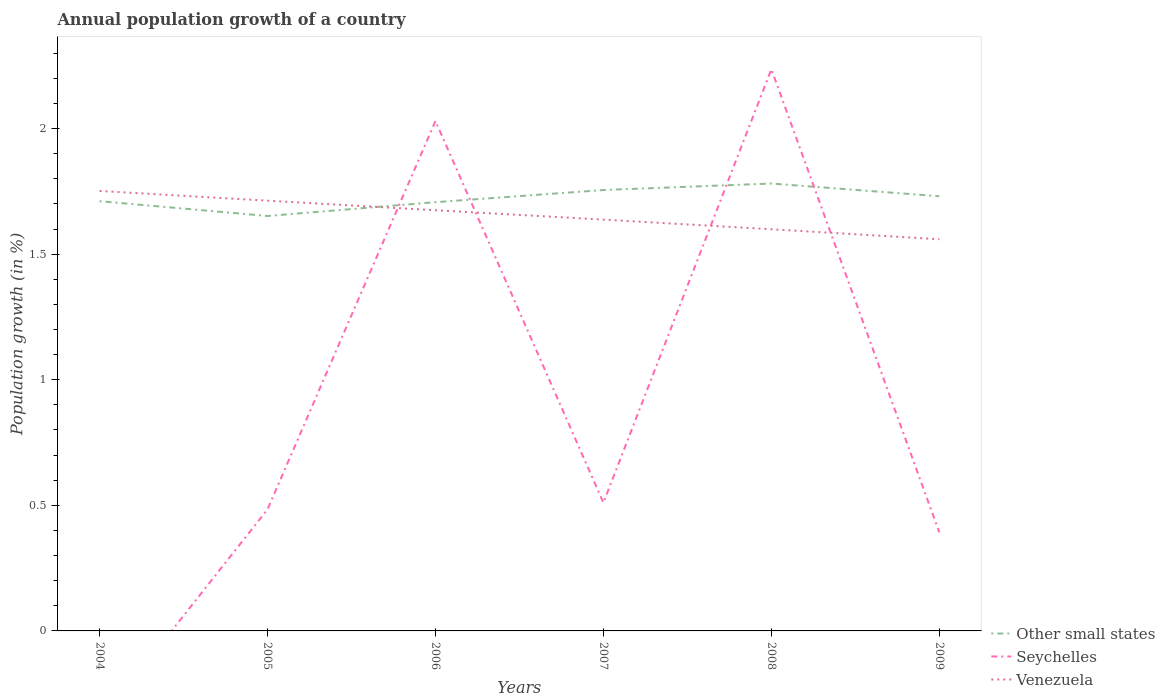How many different coloured lines are there?
Provide a short and direct response. 3. Does the line corresponding to Other small states intersect with the line corresponding to Venezuela?
Provide a short and direct response. Yes. Is the number of lines equal to the number of legend labels?
Your answer should be very brief. No. Across all years, what is the maximum annual population growth in Other small states?
Your answer should be very brief. 1.65. What is the total annual population growth in Other small states in the graph?
Offer a terse response. -0.05. What is the difference between the highest and the second highest annual population growth in Venezuela?
Provide a short and direct response. 0.19. What is the difference between the highest and the lowest annual population growth in Seychelles?
Make the answer very short. 2. Is the annual population growth in Seychelles strictly greater than the annual population growth in Other small states over the years?
Your response must be concise. No. How many lines are there?
Your answer should be very brief. 3. What is the difference between two consecutive major ticks on the Y-axis?
Ensure brevity in your answer.  0.5. Are the values on the major ticks of Y-axis written in scientific E-notation?
Provide a succinct answer. No. Does the graph contain grids?
Provide a short and direct response. No. What is the title of the graph?
Give a very brief answer. Annual population growth of a country. Does "Peru" appear as one of the legend labels in the graph?
Offer a terse response. No. What is the label or title of the X-axis?
Your answer should be compact. Years. What is the label or title of the Y-axis?
Offer a very short reply. Population growth (in %). What is the Population growth (in %) in Other small states in 2004?
Give a very brief answer. 1.71. What is the Population growth (in %) in Venezuela in 2004?
Your response must be concise. 1.75. What is the Population growth (in %) in Other small states in 2005?
Provide a succinct answer. 1.65. What is the Population growth (in %) of Seychelles in 2005?
Your response must be concise. 0.48. What is the Population growth (in %) in Venezuela in 2005?
Provide a short and direct response. 1.71. What is the Population growth (in %) in Other small states in 2006?
Your answer should be very brief. 1.71. What is the Population growth (in %) in Seychelles in 2006?
Give a very brief answer. 2.03. What is the Population growth (in %) in Venezuela in 2006?
Offer a very short reply. 1.67. What is the Population growth (in %) of Other small states in 2007?
Provide a short and direct response. 1.76. What is the Population growth (in %) of Seychelles in 2007?
Your answer should be very brief. 0.51. What is the Population growth (in %) in Venezuela in 2007?
Make the answer very short. 1.64. What is the Population growth (in %) in Other small states in 2008?
Offer a very short reply. 1.78. What is the Population growth (in %) in Seychelles in 2008?
Your answer should be very brief. 2.24. What is the Population growth (in %) of Venezuela in 2008?
Offer a very short reply. 1.6. What is the Population growth (in %) of Other small states in 2009?
Offer a very short reply. 1.73. What is the Population growth (in %) of Seychelles in 2009?
Offer a terse response. 0.39. What is the Population growth (in %) in Venezuela in 2009?
Ensure brevity in your answer.  1.56. Across all years, what is the maximum Population growth (in %) of Other small states?
Your answer should be very brief. 1.78. Across all years, what is the maximum Population growth (in %) of Seychelles?
Make the answer very short. 2.24. Across all years, what is the maximum Population growth (in %) of Venezuela?
Ensure brevity in your answer.  1.75. Across all years, what is the minimum Population growth (in %) of Other small states?
Your answer should be compact. 1.65. Across all years, what is the minimum Population growth (in %) in Venezuela?
Provide a succinct answer. 1.56. What is the total Population growth (in %) in Other small states in the graph?
Keep it short and to the point. 10.34. What is the total Population growth (in %) of Seychelles in the graph?
Ensure brevity in your answer.  5.65. What is the total Population growth (in %) of Venezuela in the graph?
Your response must be concise. 9.94. What is the difference between the Population growth (in %) in Other small states in 2004 and that in 2005?
Your response must be concise. 0.06. What is the difference between the Population growth (in %) in Venezuela in 2004 and that in 2005?
Give a very brief answer. 0.04. What is the difference between the Population growth (in %) of Other small states in 2004 and that in 2006?
Your response must be concise. 0. What is the difference between the Population growth (in %) in Venezuela in 2004 and that in 2006?
Your answer should be compact. 0.08. What is the difference between the Population growth (in %) in Other small states in 2004 and that in 2007?
Offer a terse response. -0.04. What is the difference between the Population growth (in %) of Venezuela in 2004 and that in 2007?
Your answer should be very brief. 0.11. What is the difference between the Population growth (in %) of Other small states in 2004 and that in 2008?
Offer a very short reply. -0.07. What is the difference between the Population growth (in %) in Venezuela in 2004 and that in 2008?
Offer a very short reply. 0.15. What is the difference between the Population growth (in %) in Other small states in 2004 and that in 2009?
Your answer should be compact. -0.02. What is the difference between the Population growth (in %) of Venezuela in 2004 and that in 2009?
Your answer should be very brief. 0.19. What is the difference between the Population growth (in %) of Other small states in 2005 and that in 2006?
Offer a very short reply. -0.05. What is the difference between the Population growth (in %) in Seychelles in 2005 and that in 2006?
Your answer should be compact. -1.55. What is the difference between the Population growth (in %) in Venezuela in 2005 and that in 2006?
Offer a terse response. 0.04. What is the difference between the Population growth (in %) in Other small states in 2005 and that in 2007?
Give a very brief answer. -0.1. What is the difference between the Population growth (in %) of Seychelles in 2005 and that in 2007?
Ensure brevity in your answer.  -0.03. What is the difference between the Population growth (in %) in Venezuela in 2005 and that in 2007?
Ensure brevity in your answer.  0.08. What is the difference between the Population growth (in %) of Other small states in 2005 and that in 2008?
Offer a terse response. -0.13. What is the difference between the Population growth (in %) in Seychelles in 2005 and that in 2008?
Make the answer very short. -1.75. What is the difference between the Population growth (in %) of Venezuela in 2005 and that in 2008?
Offer a terse response. 0.11. What is the difference between the Population growth (in %) in Other small states in 2005 and that in 2009?
Your response must be concise. -0.08. What is the difference between the Population growth (in %) of Seychelles in 2005 and that in 2009?
Make the answer very short. 0.09. What is the difference between the Population growth (in %) in Venezuela in 2005 and that in 2009?
Your answer should be compact. 0.15. What is the difference between the Population growth (in %) of Other small states in 2006 and that in 2007?
Your response must be concise. -0.05. What is the difference between the Population growth (in %) of Seychelles in 2006 and that in 2007?
Make the answer very short. 1.52. What is the difference between the Population growth (in %) in Venezuela in 2006 and that in 2007?
Make the answer very short. 0.04. What is the difference between the Population growth (in %) in Other small states in 2006 and that in 2008?
Provide a succinct answer. -0.07. What is the difference between the Population growth (in %) of Seychelles in 2006 and that in 2008?
Offer a terse response. -0.21. What is the difference between the Population growth (in %) in Venezuela in 2006 and that in 2008?
Give a very brief answer. 0.08. What is the difference between the Population growth (in %) in Other small states in 2006 and that in 2009?
Ensure brevity in your answer.  -0.02. What is the difference between the Population growth (in %) in Seychelles in 2006 and that in 2009?
Provide a short and direct response. 1.64. What is the difference between the Population growth (in %) of Venezuela in 2006 and that in 2009?
Keep it short and to the point. 0.12. What is the difference between the Population growth (in %) of Other small states in 2007 and that in 2008?
Offer a terse response. -0.03. What is the difference between the Population growth (in %) in Seychelles in 2007 and that in 2008?
Provide a succinct answer. -1.73. What is the difference between the Population growth (in %) of Venezuela in 2007 and that in 2008?
Ensure brevity in your answer.  0.04. What is the difference between the Population growth (in %) of Other small states in 2007 and that in 2009?
Offer a terse response. 0.02. What is the difference between the Population growth (in %) of Seychelles in 2007 and that in 2009?
Offer a very short reply. 0.12. What is the difference between the Population growth (in %) in Venezuela in 2007 and that in 2009?
Your answer should be very brief. 0.08. What is the difference between the Population growth (in %) of Other small states in 2008 and that in 2009?
Make the answer very short. 0.05. What is the difference between the Population growth (in %) of Seychelles in 2008 and that in 2009?
Your answer should be very brief. 1.84. What is the difference between the Population growth (in %) in Venezuela in 2008 and that in 2009?
Give a very brief answer. 0.04. What is the difference between the Population growth (in %) in Other small states in 2004 and the Population growth (in %) in Seychelles in 2005?
Your answer should be very brief. 1.23. What is the difference between the Population growth (in %) of Other small states in 2004 and the Population growth (in %) of Venezuela in 2005?
Give a very brief answer. -0. What is the difference between the Population growth (in %) of Other small states in 2004 and the Population growth (in %) of Seychelles in 2006?
Keep it short and to the point. -0.32. What is the difference between the Population growth (in %) in Other small states in 2004 and the Population growth (in %) in Venezuela in 2006?
Ensure brevity in your answer.  0.04. What is the difference between the Population growth (in %) of Other small states in 2004 and the Population growth (in %) of Seychelles in 2007?
Your answer should be compact. 1.2. What is the difference between the Population growth (in %) of Other small states in 2004 and the Population growth (in %) of Venezuela in 2007?
Provide a short and direct response. 0.07. What is the difference between the Population growth (in %) of Other small states in 2004 and the Population growth (in %) of Seychelles in 2008?
Provide a short and direct response. -0.53. What is the difference between the Population growth (in %) in Other small states in 2004 and the Population growth (in %) in Venezuela in 2008?
Provide a succinct answer. 0.11. What is the difference between the Population growth (in %) of Other small states in 2004 and the Population growth (in %) of Seychelles in 2009?
Make the answer very short. 1.32. What is the difference between the Population growth (in %) of Other small states in 2004 and the Population growth (in %) of Venezuela in 2009?
Offer a terse response. 0.15. What is the difference between the Population growth (in %) in Other small states in 2005 and the Population growth (in %) in Seychelles in 2006?
Offer a very short reply. -0.38. What is the difference between the Population growth (in %) of Other small states in 2005 and the Population growth (in %) of Venezuela in 2006?
Provide a succinct answer. -0.02. What is the difference between the Population growth (in %) in Seychelles in 2005 and the Population growth (in %) in Venezuela in 2006?
Your answer should be compact. -1.19. What is the difference between the Population growth (in %) in Other small states in 2005 and the Population growth (in %) in Seychelles in 2007?
Make the answer very short. 1.14. What is the difference between the Population growth (in %) of Other small states in 2005 and the Population growth (in %) of Venezuela in 2007?
Give a very brief answer. 0.01. What is the difference between the Population growth (in %) in Seychelles in 2005 and the Population growth (in %) in Venezuela in 2007?
Keep it short and to the point. -1.15. What is the difference between the Population growth (in %) of Other small states in 2005 and the Population growth (in %) of Seychelles in 2008?
Give a very brief answer. -0.58. What is the difference between the Population growth (in %) in Other small states in 2005 and the Population growth (in %) in Venezuela in 2008?
Your answer should be very brief. 0.05. What is the difference between the Population growth (in %) of Seychelles in 2005 and the Population growth (in %) of Venezuela in 2008?
Make the answer very short. -1.12. What is the difference between the Population growth (in %) of Other small states in 2005 and the Population growth (in %) of Seychelles in 2009?
Make the answer very short. 1.26. What is the difference between the Population growth (in %) in Other small states in 2005 and the Population growth (in %) in Venezuela in 2009?
Provide a succinct answer. 0.09. What is the difference between the Population growth (in %) of Seychelles in 2005 and the Population growth (in %) of Venezuela in 2009?
Provide a short and direct response. -1.08. What is the difference between the Population growth (in %) in Other small states in 2006 and the Population growth (in %) in Seychelles in 2007?
Your answer should be compact. 1.2. What is the difference between the Population growth (in %) in Other small states in 2006 and the Population growth (in %) in Venezuela in 2007?
Ensure brevity in your answer.  0.07. What is the difference between the Population growth (in %) in Seychelles in 2006 and the Population growth (in %) in Venezuela in 2007?
Give a very brief answer. 0.39. What is the difference between the Population growth (in %) of Other small states in 2006 and the Population growth (in %) of Seychelles in 2008?
Keep it short and to the point. -0.53. What is the difference between the Population growth (in %) of Other small states in 2006 and the Population growth (in %) of Venezuela in 2008?
Offer a terse response. 0.11. What is the difference between the Population growth (in %) of Seychelles in 2006 and the Population growth (in %) of Venezuela in 2008?
Keep it short and to the point. 0.43. What is the difference between the Population growth (in %) of Other small states in 2006 and the Population growth (in %) of Seychelles in 2009?
Your response must be concise. 1.31. What is the difference between the Population growth (in %) in Other small states in 2006 and the Population growth (in %) in Venezuela in 2009?
Provide a short and direct response. 0.15. What is the difference between the Population growth (in %) of Seychelles in 2006 and the Population growth (in %) of Venezuela in 2009?
Offer a terse response. 0.47. What is the difference between the Population growth (in %) in Other small states in 2007 and the Population growth (in %) in Seychelles in 2008?
Ensure brevity in your answer.  -0.48. What is the difference between the Population growth (in %) in Other small states in 2007 and the Population growth (in %) in Venezuela in 2008?
Your answer should be very brief. 0.16. What is the difference between the Population growth (in %) of Seychelles in 2007 and the Population growth (in %) of Venezuela in 2008?
Provide a short and direct response. -1.09. What is the difference between the Population growth (in %) of Other small states in 2007 and the Population growth (in %) of Seychelles in 2009?
Give a very brief answer. 1.36. What is the difference between the Population growth (in %) in Other small states in 2007 and the Population growth (in %) in Venezuela in 2009?
Ensure brevity in your answer.  0.2. What is the difference between the Population growth (in %) of Seychelles in 2007 and the Population growth (in %) of Venezuela in 2009?
Provide a short and direct response. -1.05. What is the difference between the Population growth (in %) in Other small states in 2008 and the Population growth (in %) in Seychelles in 2009?
Keep it short and to the point. 1.39. What is the difference between the Population growth (in %) in Other small states in 2008 and the Population growth (in %) in Venezuela in 2009?
Your answer should be very brief. 0.22. What is the difference between the Population growth (in %) of Seychelles in 2008 and the Population growth (in %) of Venezuela in 2009?
Provide a short and direct response. 0.68. What is the average Population growth (in %) in Other small states per year?
Keep it short and to the point. 1.72. What is the average Population growth (in %) of Seychelles per year?
Ensure brevity in your answer.  0.94. What is the average Population growth (in %) of Venezuela per year?
Offer a very short reply. 1.66. In the year 2004, what is the difference between the Population growth (in %) in Other small states and Population growth (in %) in Venezuela?
Offer a very short reply. -0.04. In the year 2005, what is the difference between the Population growth (in %) in Other small states and Population growth (in %) in Seychelles?
Keep it short and to the point. 1.17. In the year 2005, what is the difference between the Population growth (in %) in Other small states and Population growth (in %) in Venezuela?
Ensure brevity in your answer.  -0.06. In the year 2005, what is the difference between the Population growth (in %) of Seychelles and Population growth (in %) of Venezuela?
Your answer should be very brief. -1.23. In the year 2006, what is the difference between the Population growth (in %) of Other small states and Population growth (in %) of Seychelles?
Give a very brief answer. -0.32. In the year 2006, what is the difference between the Population growth (in %) in Other small states and Population growth (in %) in Venezuela?
Keep it short and to the point. 0.03. In the year 2006, what is the difference between the Population growth (in %) of Seychelles and Population growth (in %) of Venezuela?
Offer a terse response. 0.36. In the year 2007, what is the difference between the Population growth (in %) of Other small states and Population growth (in %) of Seychelles?
Keep it short and to the point. 1.24. In the year 2007, what is the difference between the Population growth (in %) of Other small states and Population growth (in %) of Venezuela?
Provide a succinct answer. 0.12. In the year 2007, what is the difference between the Population growth (in %) in Seychelles and Population growth (in %) in Venezuela?
Offer a very short reply. -1.13. In the year 2008, what is the difference between the Population growth (in %) in Other small states and Population growth (in %) in Seychelles?
Offer a very short reply. -0.46. In the year 2008, what is the difference between the Population growth (in %) of Other small states and Population growth (in %) of Venezuela?
Your answer should be compact. 0.18. In the year 2008, what is the difference between the Population growth (in %) in Seychelles and Population growth (in %) in Venezuela?
Ensure brevity in your answer.  0.64. In the year 2009, what is the difference between the Population growth (in %) of Other small states and Population growth (in %) of Seychelles?
Provide a succinct answer. 1.34. In the year 2009, what is the difference between the Population growth (in %) in Other small states and Population growth (in %) in Venezuela?
Give a very brief answer. 0.17. In the year 2009, what is the difference between the Population growth (in %) of Seychelles and Population growth (in %) of Venezuela?
Your answer should be compact. -1.17. What is the ratio of the Population growth (in %) in Other small states in 2004 to that in 2005?
Give a very brief answer. 1.04. What is the ratio of the Population growth (in %) in Venezuela in 2004 to that in 2005?
Ensure brevity in your answer.  1.02. What is the ratio of the Population growth (in %) of Venezuela in 2004 to that in 2006?
Ensure brevity in your answer.  1.05. What is the ratio of the Population growth (in %) in Other small states in 2004 to that in 2007?
Your response must be concise. 0.97. What is the ratio of the Population growth (in %) in Venezuela in 2004 to that in 2007?
Ensure brevity in your answer.  1.07. What is the ratio of the Population growth (in %) of Other small states in 2004 to that in 2008?
Provide a succinct answer. 0.96. What is the ratio of the Population growth (in %) of Venezuela in 2004 to that in 2008?
Make the answer very short. 1.1. What is the ratio of the Population growth (in %) of Venezuela in 2004 to that in 2009?
Provide a succinct answer. 1.12. What is the ratio of the Population growth (in %) of Other small states in 2005 to that in 2006?
Provide a succinct answer. 0.97. What is the ratio of the Population growth (in %) in Seychelles in 2005 to that in 2006?
Give a very brief answer. 0.24. What is the ratio of the Population growth (in %) of Venezuela in 2005 to that in 2006?
Keep it short and to the point. 1.02. What is the ratio of the Population growth (in %) of Other small states in 2005 to that in 2007?
Offer a very short reply. 0.94. What is the ratio of the Population growth (in %) in Seychelles in 2005 to that in 2007?
Provide a short and direct response. 0.95. What is the ratio of the Population growth (in %) of Venezuela in 2005 to that in 2007?
Provide a succinct answer. 1.05. What is the ratio of the Population growth (in %) in Other small states in 2005 to that in 2008?
Give a very brief answer. 0.93. What is the ratio of the Population growth (in %) of Seychelles in 2005 to that in 2008?
Provide a succinct answer. 0.22. What is the ratio of the Population growth (in %) of Venezuela in 2005 to that in 2008?
Keep it short and to the point. 1.07. What is the ratio of the Population growth (in %) in Other small states in 2005 to that in 2009?
Ensure brevity in your answer.  0.95. What is the ratio of the Population growth (in %) of Seychelles in 2005 to that in 2009?
Make the answer very short. 1.23. What is the ratio of the Population growth (in %) in Venezuela in 2005 to that in 2009?
Provide a succinct answer. 1.1. What is the ratio of the Population growth (in %) of Other small states in 2006 to that in 2007?
Provide a short and direct response. 0.97. What is the ratio of the Population growth (in %) of Seychelles in 2006 to that in 2007?
Offer a very short reply. 3.98. What is the ratio of the Population growth (in %) in Venezuela in 2006 to that in 2007?
Your response must be concise. 1.02. What is the ratio of the Population growth (in %) in Seychelles in 2006 to that in 2008?
Give a very brief answer. 0.91. What is the ratio of the Population growth (in %) of Venezuela in 2006 to that in 2008?
Provide a succinct answer. 1.05. What is the ratio of the Population growth (in %) in Other small states in 2006 to that in 2009?
Give a very brief answer. 0.99. What is the ratio of the Population growth (in %) of Seychelles in 2006 to that in 2009?
Ensure brevity in your answer.  5.17. What is the ratio of the Population growth (in %) of Venezuela in 2006 to that in 2009?
Offer a terse response. 1.07. What is the ratio of the Population growth (in %) of Other small states in 2007 to that in 2008?
Your response must be concise. 0.99. What is the ratio of the Population growth (in %) in Seychelles in 2007 to that in 2008?
Your response must be concise. 0.23. What is the ratio of the Population growth (in %) in Venezuela in 2007 to that in 2008?
Ensure brevity in your answer.  1.02. What is the ratio of the Population growth (in %) in Other small states in 2007 to that in 2009?
Your answer should be very brief. 1.01. What is the ratio of the Population growth (in %) of Seychelles in 2007 to that in 2009?
Keep it short and to the point. 1.3. What is the ratio of the Population growth (in %) of Venezuela in 2007 to that in 2009?
Offer a terse response. 1.05. What is the ratio of the Population growth (in %) of Other small states in 2008 to that in 2009?
Keep it short and to the point. 1.03. What is the ratio of the Population growth (in %) of Seychelles in 2008 to that in 2009?
Offer a very short reply. 5.7. What is the ratio of the Population growth (in %) in Venezuela in 2008 to that in 2009?
Your response must be concise. 1.03. What is the difference between the highest and the second highest Population growth (in %) of Other small states?
Your answer should be compact. 0.03. What is the difference between the highest and the second highest Population growth (in %) of Seychelles?
Offer a terse response. 0.21. What is the difference between the highest and the second highest Population growth (in %) of Venezuela?
Provide a succinct answer. 0.04. What is the difference between the highest and the lowest Population growth (in %) of Other small states?
Offer a terse response. 0.13. What is the difference between the highest and the lowest Population growth (in %) of Seychelles?
Provide a succinct answer. 2.24. What is the difference between the highest and the lowest Population growth (in %) in Venezuela?
Provide a short and direct response. 0.19. 